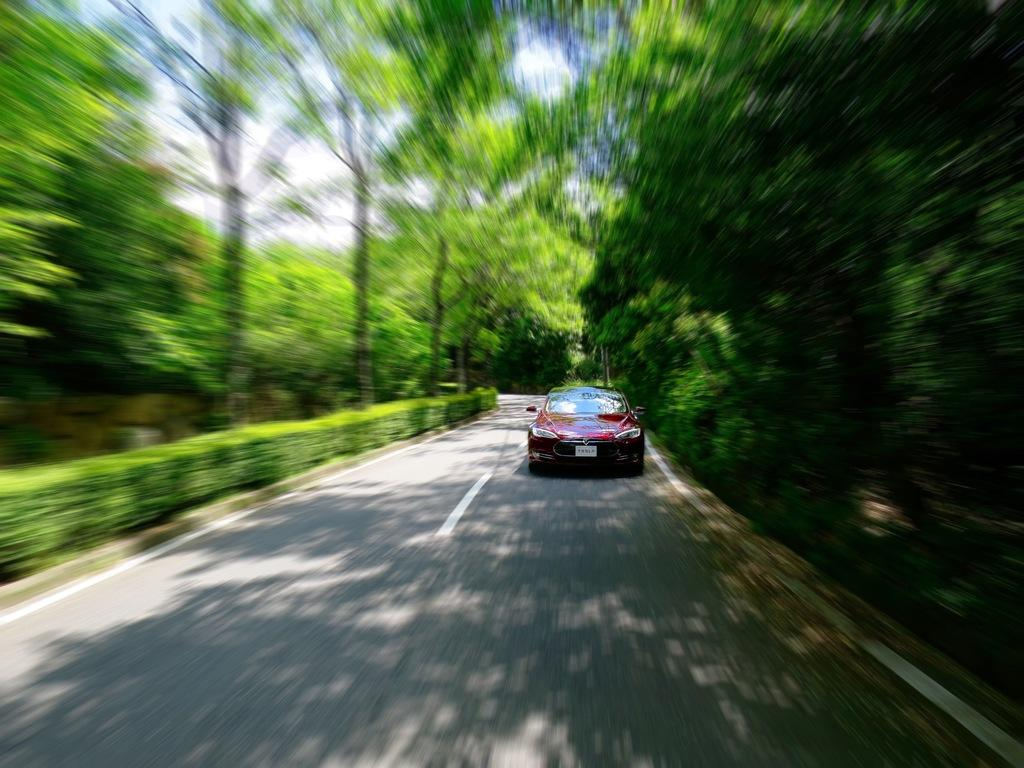What is the main subject of the image? The main subject of the image is a car. What is the car doing in the image? The car is moving on the road. Can you describe the background of the image? The background of the image is blurred. What type of natural elements can be seen in the image? Trees are visible in the image. What is visible at the top of the image? The sky is visible at the top of the image. What grade does the car receive for its performance in the image? There is no grade assigned to the car's performance in the image, as it is not an evaluation or assessment. --- Facts: 1. There is a person sitting on a bench in the image. 2. The person is reading a book. 3. The bench is located in a park. 4. There are trees in the background of the image. 5. The sky is visible at the top of the image. Absurd Topics: dance, ocean, instrument Conversation: What is the person in the image doing? The person is sitting on a bench and reading a book. Where is the bench located? The bench is located in a park. What can be seen in the background of the image? There are trees in the background of the image. What is visible at the top of the image? The sky is visible at the top of the image. Reasoning: Let's think step by step in order to produce the conversation. We start by identifying the main subject of the image, which is the person sitting on a bench. Then, we describe the action of the person, which is reading a book. Next, we mention the location of the bench, which is in a park. We then identify the natural elements present in the image, which are trees. Finally, we describe the sky visible at the top of the image. Absurd Question/Answer: What type of dance is the person performing in the image? There is no indication in the image that the person is dancing, as they are sitting on a bench and reading a book. --- Facts: 1. There is a group of people standing in a circle in the image. 2. The people are holding hands. 3. The background of the image is a grassy field. 4. There are trees visible in the background of the image. 5. The sky is visible at the top of the image. Absurd Topics: robot, ocean, painting Conversation: What are the people in the image doing? The people are standing in a circle and holding hands. What can be seen in the background of the image? The background of the image is a grassy field. What type of natural elements can be seen in the image? Trees are visible in the background of the 